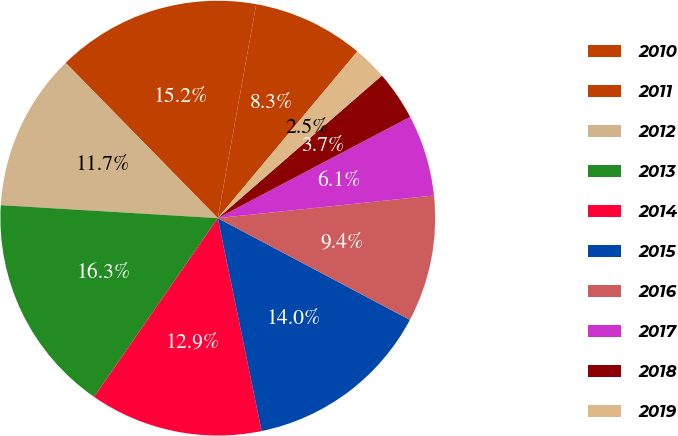Convert chart to OTSL. <chart><loc_0><loc_0><loc_500><loc_500><pie_chart><fcel>2010<fcel>2011<fcel>2012<fcel>2013<fcel>2014<fcel>2015<fcel>2016<fcel>2017<fcel>2018<fcel>2019<nl><fcel>8.26%<fcel>15.16%<fcel>11.71%<fcel>16.31%<fcel>12.86%<fcel>14.01%<fcel>9.41%<fcel>6.05%<fcel>3.67%<fcel>2.52%<nl></chart> 